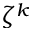<formula> <loc_0><loc_0><loc_500><loc_500>\zeta ^ { k }</formula> 